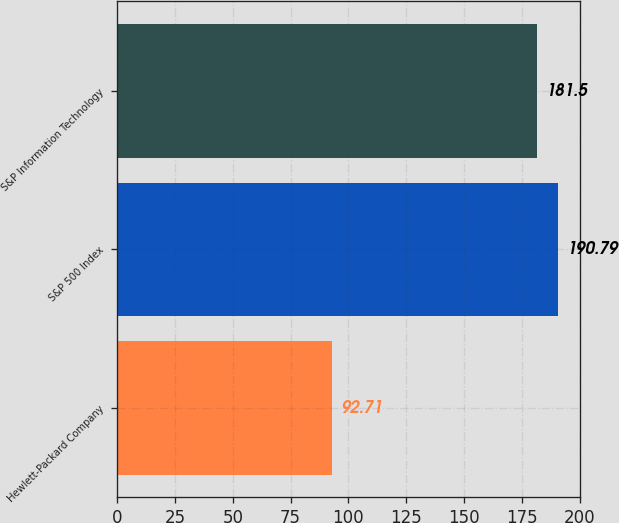<chart> <loc_0><loc_0><loc_500><loc_500><bar_chart><fcel>Hewlett-Packard Company<fcel>S&P 500 Index<fcel>S&P Information Technology<nl><fcel>92.71<fcel>190.79<fcel>181.5<nl></chart> 